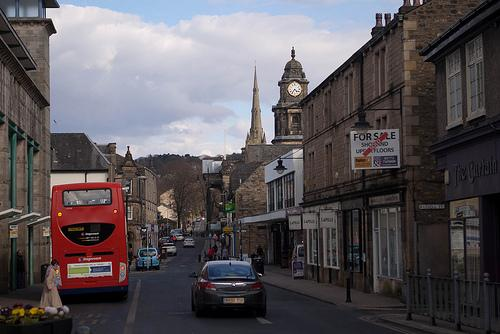What kind of sign is on the building and what does it possibly signify? There is a white sign on the building, which possibly indicates a for sale notice. Identify the primary mode of transportation present in the image and its color. The primary mode of transportation is a red bus. In the image, describe a type of fence that you see and where it is located. There is a gray metal post fence on the street. How many people are visible in this image? Describe the attire of one of them. There are two people visible in the image. One of them is a woman wearing a long coat. Describe one small detail you notice about a vehicle in the picture. The gray car has tail lights turned on. What natural feature can be seen in the image's background? A mountain can be seen in the background. Count the number of different types of vehicles depicted in the image. There are three different types of vehicles: red bus, gray car, and blue van. What kind of vehicle is parked on the side of the street and what color is it? A red bus is parked on the side of the street. Mention a prominent architectural feature found on top of a building in the photo. A clock tower is seen on top of a building. Can you describe the weather based on the clouds in the sky? The weather appears to be pleasant, with white clouds in a blue sky. Do you see a helicopter in the sky? There are several mentions of clouds in the sky, but no helicopter is mentioned. Do you see any orange flowers beside the street? There is a mention of flowers beside the street, but their color is not specified. So, assuming they are orange might be misleading. Is there a purple car driving in both lanes? There is a gray car driving in both lanes, but no purple car is mentioned. Can you find a blue fence on the sidewalk? There is a mention of a gray metal post fence on the street, but no blue fence is mentioned. Can you find a dog walking behind the red bus? There is a mention of a person walking behind the bus, but no dog is mentioned. Is there a green bus on the street? There are multiple mentions of a red bus, but no green bus is mentioned. 